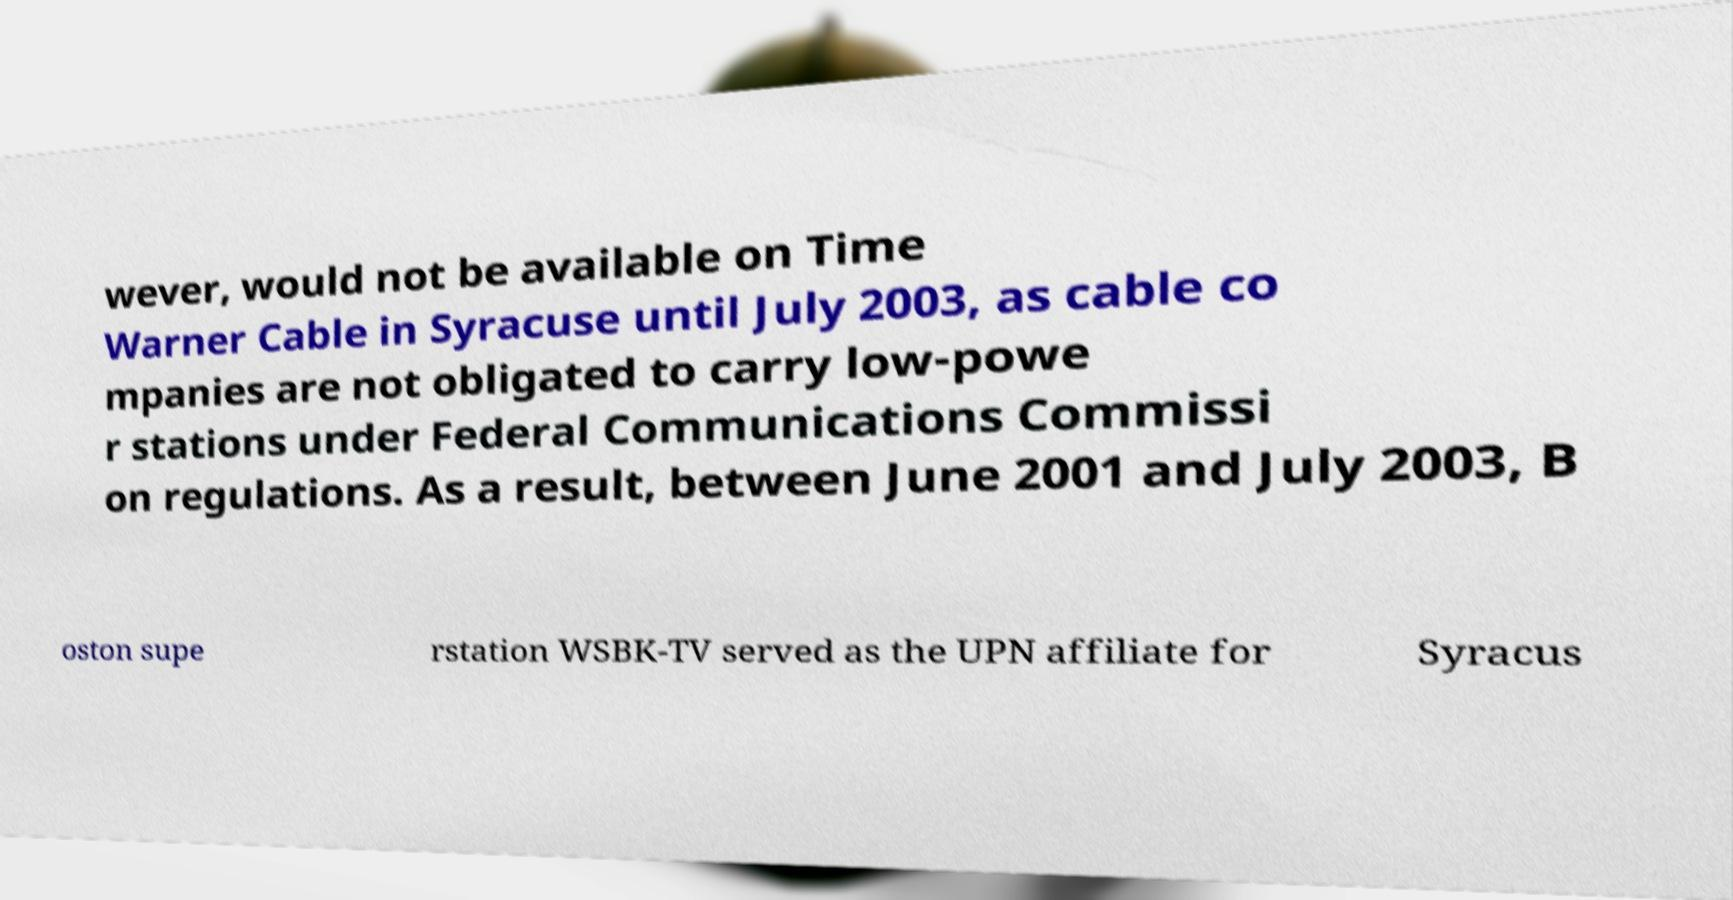Can you read and provide the text displayed in the image?This photo seems to have some interesting text. Can you extract and type it out for me? wever, would not be available on Time Warner Cable in Syracuse until July 2003, as cable co mpanies are not obligated to carry low-powe r stations under Federal Communications Commissi on regulations. As a result, between June 2001 and July 2003, B oston supe rstation WSBK-TV served as the UPN affiliate for Syracus 